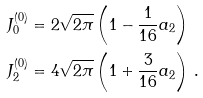<formula> <loc_0><loc_0><loc_500><loc_500>J _ { 0 } ^ { ( 0 ) } & = 2 \sqrt { 2 \pi } \left ( 1 - \frac { 1 } { 1 6 } a _ { 2 } \right ) \\ J _ { 2 } ^ { ( 0 ) } & = 4 \sqrt { 2 \pi } \left ( 1 + \frac { 3 } { 1 6 } a _ { 2 } \right ) \, .</formula> 